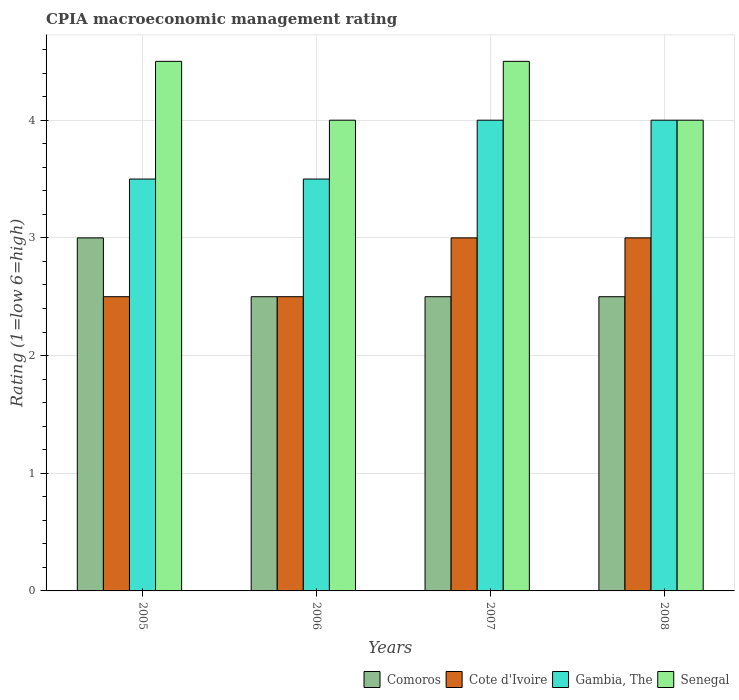How many different coloured bars are there?
Keep it short and to the point. 4. Are the number of bars per tick equal to the number of legend labels?
Provide a short and direct response. Yes. How many bars are there on the 2nd tick from the right?
Make the answer very short. 4. In how many cases, is the number of bars for a given year not equal to the number of legend labels?
Your answer should be very brief. 0. What is the CPIA rating in Comoros in 2006?
Provide a succinct answer. 2.5. In which year was the CPIA rating in Comoros maximum?
Offer a very short reply. 2005. What is the difference between the CPIA rating in Senegal in 2005 and that in 2007?
Keep it short and to the point. 0. What is the difference between the CPIA rating in Senegal in 2007 and the CPIA rating in Gambia, The in 2005?
Give a very brief answer. 1. What is the average CPIA rating in Gambia, The per year?
Offer a very short reply. 3.75. Is the CPIA rating in Comoros in 2005 less than that in 2006?
Provide a succinct answer. No. Is the difference between the CPIA rating in Senegal in 2006 and 2008 greater than the difference between the CPIA rating in Cote d'Ivoire in 2006 and 2008?
Your answer should be compact. Yes. What is the difference between the highest and the second highest CPIA rating in Cote d'Ivoire?
Make the answer very short. 0. Is it the case that in every year, the sum of the CPIA rating in Gambia, The and CPIA rating in Cote d'Ivoire is greater than the sum of CPIA rating in Senegal and CPIA rating in Comoros?
Give a very brief answer. Yes. What does the 1st bar from the left in 2006 represents?
Provide a succinct answer. Comoros. What does the 4th bar from the right in 2005 represents?
Provide a succinct answer. Comoros. What is the difference between two consecutive major ticks on the Y-axis?
Your answer should be very brief. 1. Does the graph contain any zero values?
Provide a succinct answer. No. Does the graph contain grids?
Your answer should be compact. Yes. How many legend labels are there?
Your response must be concise. 4. What is the title of the graph?
Ensure brevity in your answer.  CPIA macroeconomic management rating. What is the label or title of the X-axis?
Ensure brevity in your answer.  Years. What is the label or title of the Y-axis?
Make the answer very short. Rating (1=low 6=high). What is the Rating (1=low 6=high) of Gambia, The in 2005?
Ensure brevity in your answer.  3.5. What is the Rating (1=low 6=high) of Senegal in 2005?
Ensure brevity in your answer.  4.5. What is the Rating (1=low 6=high) in Cote d'Ivoire in 2006?
Offer a terse response. 2.5. What is the Rating (1=low 6=high) of Senegal in 2006?
Provide a succinct answer. 4. What is the Rating (1=low 6=high) in Comoros in 2007?
Ensure brevity in your answer.  2.5. What is the Rating (1=low 6=high) in Gambia, The in 2007?
Your response must be concise. 4. What is the Rating (1=low 6=high) in Senegal in 2007?
Provide a short and direct response. 4.5. What is the Rating (1=low 6=high) in Comoros in 2008?
Offer a terse response. 2.5. What is the Rating (1=low 6=high) in Senegal in 2008?
Make the answer very short. 4. Across all years, what is the maximum Rating (1=low 6=high) in Senegal?
Your answer should be very brief. 4.5. Across all years, what is the minimum Rating (1=low 6=high) of Cote d'Ivoire?
Give a very brief answer. 2.5. Across all years, what is the minimum Rating (1=low 6=high) of Senegal?
Offer a very short reply. 4. What is the total Rating (1=low 6=high) in Gambia, The in the graph?
Make the answer very short. 15. What is the difference between the Rating (1=low 6=high) in Comoros in 2005 and that in 2006?
Ensure brevity in your answer.  0.5. What is the difference between the Rating (1=low 6=high) in Cote d'Ivoire in 2005 and that in 2006?
Offer a terse response. 0. What is the difference between the Rating (1=low 6=high) in Comoros in 2005 and that in 2007?
Make the answer very short. 0.5. What is the difference between the Rating (1=low 6=high) in Gambia, The in 2005 and that in 2007?
Ensure brevity in your answer.  -0.5. What is the difference between the Rating (1=low 6=high) of Comoros in 2005 and that in 2008?
Make the answer very short. 0.5. What is the difference between the Rating (1=low 6=high) of Gambia, The in 2005 and that in 2008?
Offer a terse response. -0.5. What is the difference between the Rating (1=low 6=high) in Comoros in 2006 and that in 2007?
Provide a short and direct response. 0. What is the difference between the Rating (1=low 6=high) of Cote d'Ivoire in 2006 and that in 2007?
Your response must be concise. -0.5. What is the difference between the Rating (1=low 6=high) of Gambia, The in 2006 and that in 2008?
Your answer should be very brief. -0.5. What is the difference between the Rating (1=low 6=high) of Senegal in 2006 and that in 2008?
Keep it short and to the point. 0. What is the difference between the Rating (1=low 6=high) of Comoros in 2007 and that in 2008?
Make the answer very short. 0. What is the difference between the Rating (1=low 6=high) in Gambia, The in 2007 and that in 2008?
Your response must be concise. 0. What is the difference between the Rating (1=low 6=high) in Comoros in 2005 and the Rating (1=low 6=high) in Gambia, The in 2006?
Keep it short and to the point. -0.5. What is the difference between the Rating (1=low 6=high) in Comoros in 2005 and the Rating (1=low 6=high) in Senegal in 2006?
Provide a succinct answer. -1. What is the difference between the Rating (1=low 6=high) of Cote d'Ivoire in 2005 and the Rating (1=low 6=high) of Gambia, The in 2006?
Ensure brevity in your answer.  -1. What is the difference between the Rating (1=low 6=high) of Cote d'Ivoire in 2005 and the Rating (1=low 6=high) of Senegal in 2006?
Offer a terse response. -1.5. What is the difference between the Rating (1=low 6=high) in Comoros in 2005 and the Rating (1=low 6=high) in Cote d'Ivoire in 2007?
Provide a succinct answer. 0. What is the difference between the Rating (1=low 6=high) in Comoros in 2005 and the Rating (1=low 6=high) in Gambia, The in 2007?
Make the answer very short. -1. What is the difference between the Rating (1=low 6=high) of Cote d'Ivoire in 2005 and the Rating (1=low 6=high) of Gambia, The in 2007?
Offer a terse response. -1.5. What is the difference between the Rating (1=low 6=high) of Cote d'Ivoire in 2005 and the Rating (1=low 6=high) of Senegal in 2007?
Keep it short and to the point. -2. What is the difference between the Rating (1=low 6=high) of Gambia, The in 2005 and the Rating (1=low 6=high) of Senegal in 2007?
Ensure brevity in your answer.  -1. What is the difference between the Rating (1=low 6=high) in Comoros in 2005 and the Rating (1=low 6=high) in Cote d'Ivoire in 2008?
Ensure brevity in your answer.  0. What is the difference between the Rating (1=low 6=high) of Comoros in 2005 and the Rating (1=low 6=high) of Gambia, The in 2008?
Your answer should be compact. -1. What is the difference between the Rating (1=low 6=high) in Comoros in 2005 and the Rating (1=low 6=high) in Senegal in 2008?
Offer a terse response. -1. What is the difference between the Rating (1=low 6=high) in Gambia, The in 2005 and the Rating (1=low 6=high) in Senegal in 2008?
Offer a very short reply. -0.5. What is the difference between the Rating (1=low 6=high) in Cote d'Ivoire in 2006 and the Rating (1=low 6=high) in Senegal in 2007?
Make the answer very short. -2. What is the difference between the Rating (1=low 6=high) in Comoros in 2006 and the Rating (1=low 6=high) in Cote d'Ivoire in 2008?
Make the answer very short. -0.5. What is the difference between the Rating (1=low 6=high) in Comoros in 2006 and the Rating (1=low 6=high) in Gambia, The in 2008?
Offer a terse response. -1.5. What is the difference between the Rating (1=low 6=high) of Cote d'Ivoire in 2006 and the Rating (1=low 6=high) of Senegal in 2008?
Your answer should be compact. -1.5. What is the difference between the Rating (1=low 6=high) in Comoros in 2007 and the Rating (1=low 6=high) in Senegal in 2008?
Your response must be concise. -1.5. What is the difference between the Rating (1=low 6=high) of Cote d'Ivoire in 2007 and the Rating (1=low 6=high) of Gambia, The in 2008?
Your answer should be very brief. -1. What is the difference between the Rating (1=low 6=high) in Cote d'Ivoire in 2007 and the Rating (1=low 6=high) in Senegal in 2008?
Provide a short and direct response. -1. What is the average Rating (1=low 6=high) in Comoros per year?
Offer a terse response. 2.62. What is the average Rating (1=low 6=high) of Cote d'Ivoire per year?
Provide a short and direct response. 2.75. What is the average Rating (1=low 6=high) in Gambia, The per year?
Your answer should be compact. 3.75. What is the average Rating (1=low 6=high) of Senegal per year?
Your response must be concise. 4.25. In the year 2005, what is the difference between the Rating (1=low 6=high) in Comoros and Rating (1=low 6=high) in Cote d'Ivoire?
Your answer should be compact. 0.5. In the year 2005, what is the difference between the Rating (1=low 6=high) in Gambia, The and Rating (1=low 6=high) in Senegal?
Make the answer very short. -1. In the year 2006, what is the difference between the Rating (1=low 6=high) in Comoros and Rating (1=low 6=high) in Cote d'Ivoire?
Offer a very short reply. 0. In the year 2007, what is the difference between the Rating (1=low 6=high) in Comoros and Rating (1=low 6=high) in Cote d'Ivoire?
Offer a terse response. -0.5. In the year 2007, what is the difference between the Rating (1=low 6=high) in Comoros and Rating (1=low 6=high) in Gambia, The?
Offer a terse response. -1.5. In the year 2007, what is the difference between the Rating (1=low 6=high) of Comoros and Rating (1=low 6=high) of Senegal?
Provide a short and direct response. -2. In the year 2007, what is the difference between the Rating (1=low 6=high) of Cote d'Ivoire and Rating (1=low 6=high) of Gambia, The?
Ensure brevity in your answer.  -1. In the year 2008, what is the difference between the Rating (1=low 6=high) in Comoros and Rating (1=low 6=high) in Cote d'Ivoire?
Your answer should be compact. -0.5. In the year 2008, what is the difference between the Rating (1=low 6=high) of Comoros and Rating (1=low 6=high) of Gambia, The?
Provide a short and direct response. -1.5. In the year 2008, what is the difference between the Rating (1=low 6=high) of Comoros and Rating (1=low 6=high) of Senegal?
Keep it short and to the point. -1.5. In the year 2008, what is the difference between the Rating (1=low 6=high) in Cote d'Ivoire and Rating (1=low 6=high) in Gambia, The?
Keep it short and to the point. -1. In the year 2008, what is the difference between the Rating (1=low 6=high) in Cote d'Ivoire and Rating (1=low 6=high) in Senegal?
Make the answer very short. -1. What is the ratio of the Rating (1=low 6=high) in Cote d'Ivoire in 2005 to that in 2006?
Your answer should be compact. 1. What is the ratio of the Rating (1=low 6=high) in Gambia, The in 2005 to that in 2006?
Offer a very short reply. 1. What is the ratio of the Rating (1=low 6=high) of Senegal in 2005 to that in 2006?
Make the answer very short. 1.12. What is the ratio of the Rating (1=low 6=high) in Cote d'Ivoire in 2005 to that in 2007?
Ensure brevity in your answer.  0.83. What is the ratio of the Rating (1=low 6=high) of Comoros in 2005 to that in 2008?
Offer a terse response. 1.2. What is the ratio of the Rating (1=low 6=high) in Cote d'Ivoire in 2005 to that in 2008?
Offer a very short reply. 0.83. What is the ratio of the Rating (1=low 6=high) in Senegal in 2005 to that in 2008?
Make the answer very short. 1.12. What is the ratio of the Rating (1=low 6=high) of Cote d'Ivoire in 2006 to that in 2007?
Ensure brevity in your answer.  0.83. What is the ratio of the Rating (1=low 6=high) in Gambia, The in 2006 to that in 2007?
Your answer should be very brief. 0.88. What is the ratio of the Rating (1=low 6=high) of Comoros in 2006 to that in 2008?
Give a very brief answer. 1. What is the ratio of the Rating (1=low 6=high) of Gambia, The in 2006 to that in 2008?
Give a very brief answer. 0.88. What is the ratio of the Rating (1=low 6=high) in Comoros in 2007 to that in 2008?
Offer a terse response. 1. What is the ratio of the Rating (1=low 6=high) of Senegal in 2007 to that in 2008?
Ensure brevity in your answer.  1.12. What is the difference between the highest and the second highest Rating (1=low 6=high) in Comoros?
Your answer should be compact. 0.5. What is the difference between the highest and the second highest Rating (1=low 6=high) of Senegal?
Provide a succinct answer. 0. What is the difference between the highest and the lowest Rating (1=low 6=high) of Cote d'Ivoire?
Your response must be concise. 0.5. 